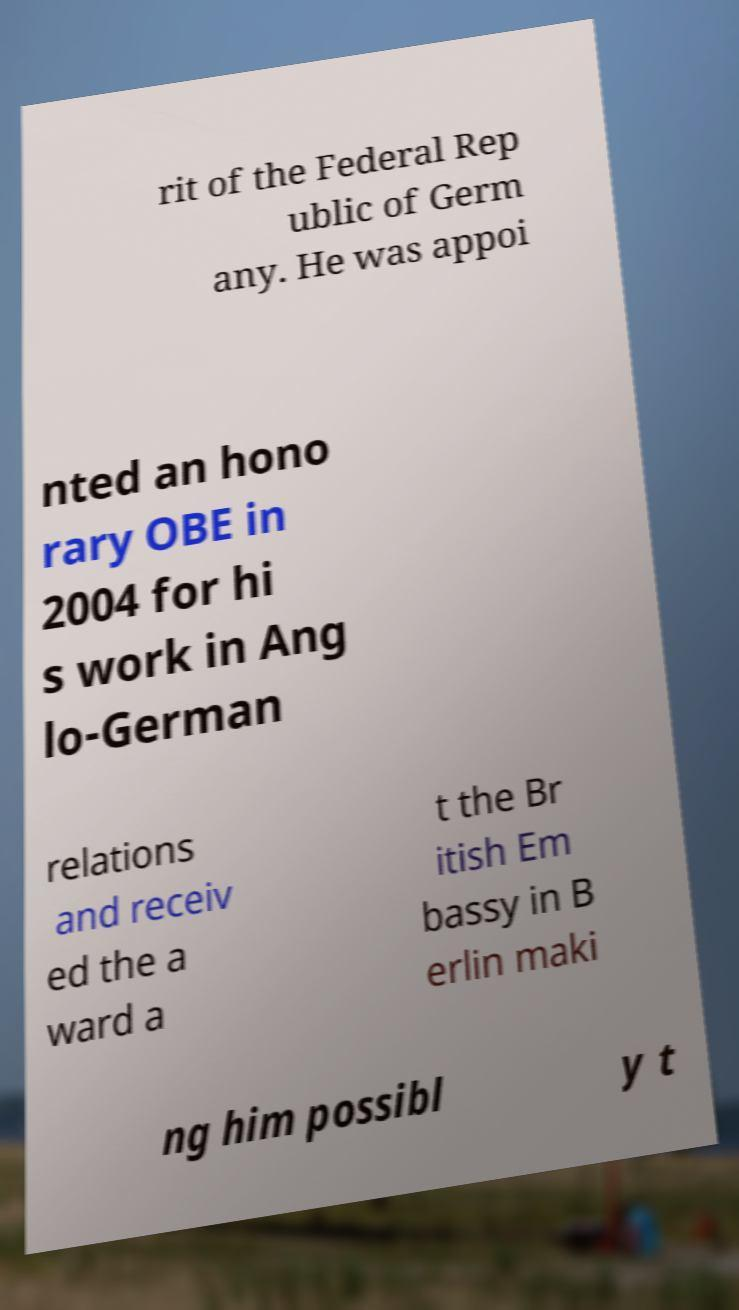Could you extract and type out the text from this image? rit of the Federal Rep ublic of Germ any. He was appoi nted an hono rary OBE in 2004 for hi s work in Ang lo-German relations and receiv ed the a ward a t the Br itish Em bassy in B erlin maki ng him possibl y t 